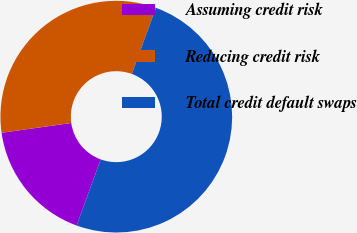<chart> <loc_0><loc_0><loc_500><loc_500><pie_chart><fcel>Assuming credit risk<fcel>Reducing credit risk<fcel>Total credit default swaps<nl><fcel>17.22%<fcel>32.78%<fcel>50.0%<nl></chart> 